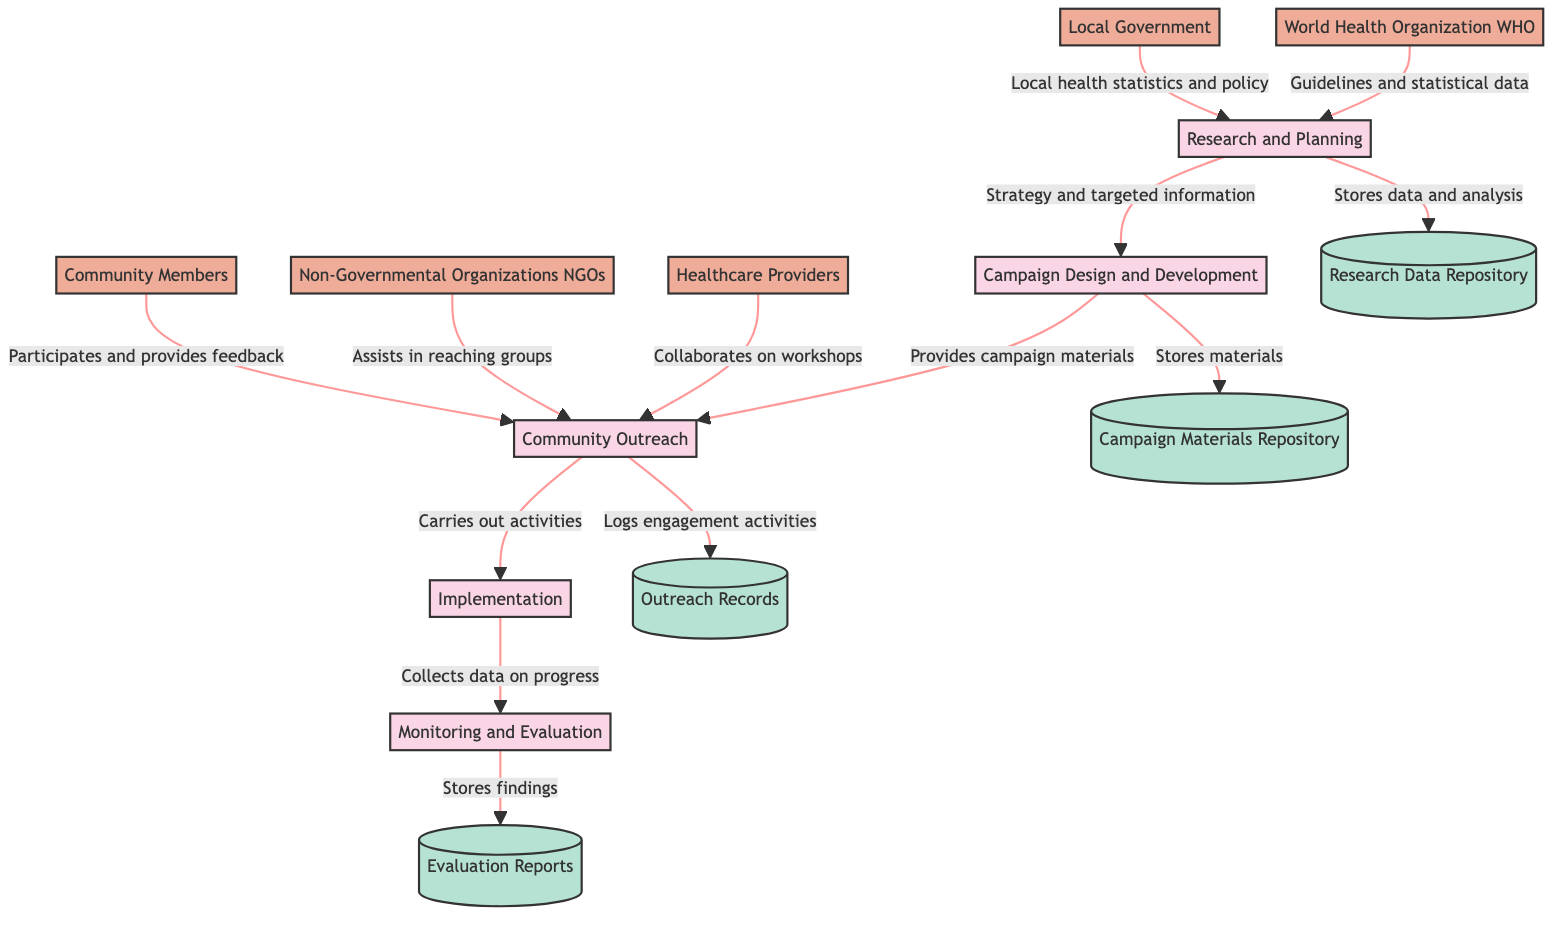What is the first process in the diagram? The first process listed is "Research and Planning," which is indicated at the top of the flow and is numbered as process 1.
Answer: Research and Planning How many external entities are present in the diagram? There are five external entities listed: World Health Organization, Local Government, Healthcare Providers, Non-Governmental Organizations, and Community Members, counting them results in a total of five.
Answer: 5 What type of data flow comes from the Local Government to the Research and Planning process? The data flow from the Local Government provides "Local health statistics and policy," indicating the specific information shared to assist in planning efforts.
Answer: Local health statistics and policy Which data store receives data from the Campaign Design and Development process? The Campaign Materials Repository receives data from the Campaign Design and Development process, as indicated by the flow that stores developed materials.
Answer: Campaign Materials Repository What is the purpose of the Monitoring and Evaluation process? The purpose of the Monitoring and Evaluation process is to track the effectiveness of the campaign and make necessary adjustments, which is defined in the description of this process.
Answer: Track the effectiveness Which external entity collaborates with Community Outreach on workshops? The external entity that collaborates with Community Outreach on workshops is Healthcare Providers, as indicated by the flow that shows collaboration for community events.
Answer: Healthcare Providers In which data store are the findings and recommendations from the Monitoring and Evaluation process stored? The findings and recommendations from the Monitoring and Evaluation process are stored in the Evaluation Reports data store, as shown by the corresponding data flow.
Answer: Evaluation Reports What is the final process that involves community-based activities? The final process that involves community-based activities is Implementation, which follows the Community Outreach process in the diagram.
Answer: Implementation How many data stores are indicated in the diagram? There are four data stores indicated: Research Data Repository, Campaign Materials Repository, Outreach Records, and Evaluation Reports. Counting them gives a total of four.
Answer: 4 